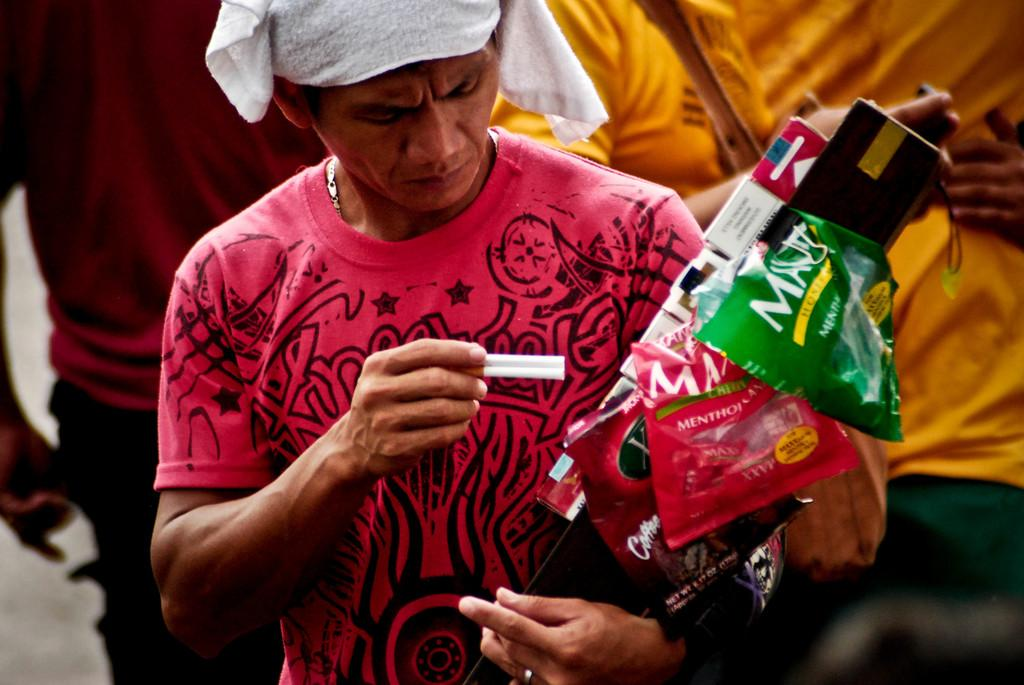What is the main subject of the image? There is a person in the image. What is the person wearing? The person is wearing a t-shirt. What is the person holding in the image? The person is holding two cigarettes. Can you describe any other objects or people in the image? There are objects in the image, and there are three people standing behind the person. What type of plantation can be seen in the background of the image? There is no plantation present in the image. 